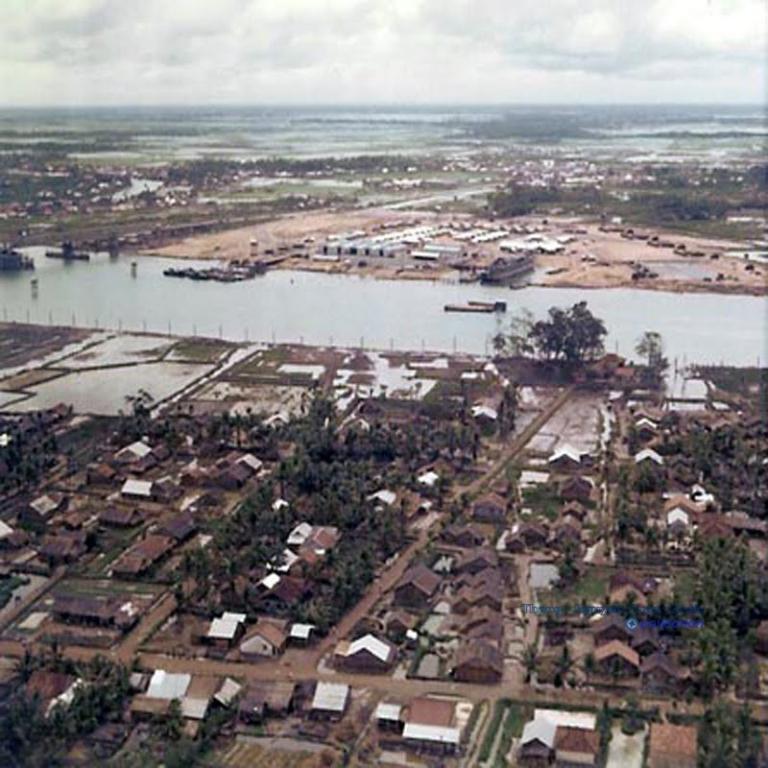How would you summarize this image in a sentence or two? There are roads, houses which are having roofs, trees and plants on the ground near a river. Outside the river, there are buildings, trees and plants on the ground and there is water on the ground. In the background, there are clouds in the sky. 